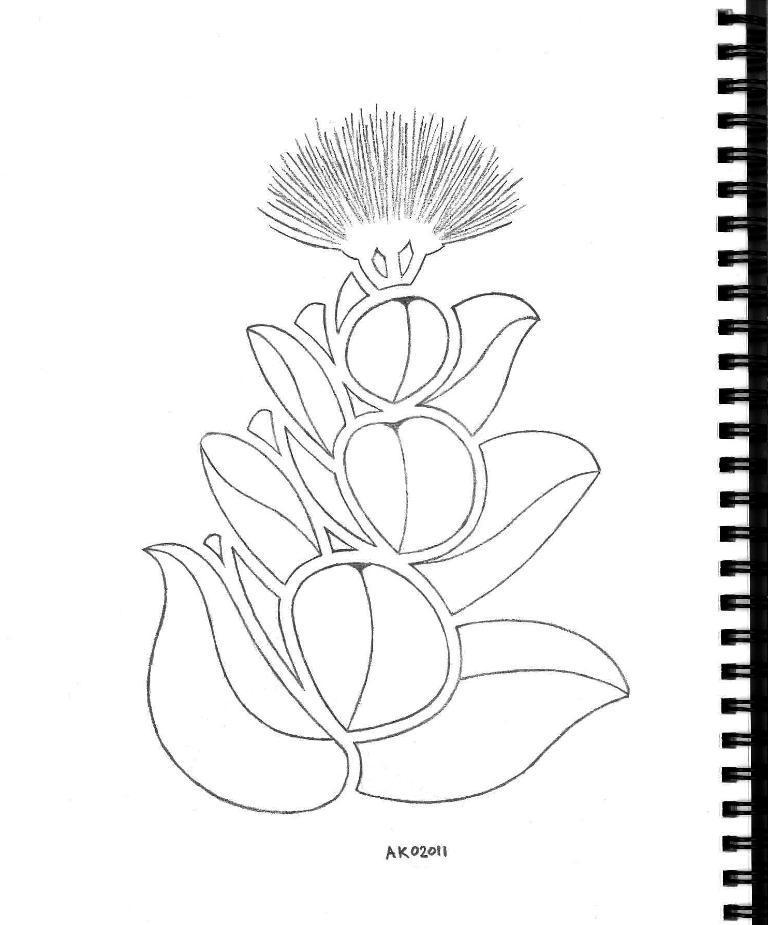In one or two sentences, can you explain what this image depicts? This looks like a pencil art on the paper. I can see the letters. This is the spiral binding with plastic coils. 